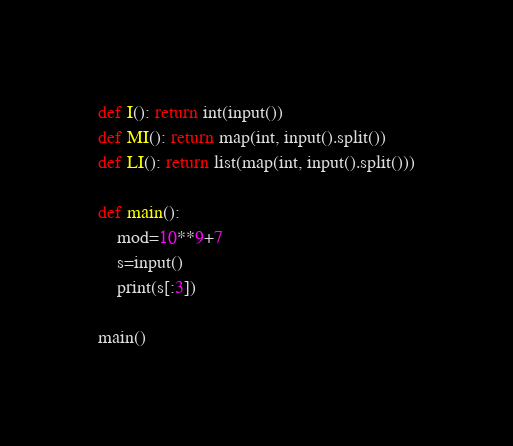Convert code to text. <code><loc_0><loc_0><loc_500><loc_500><_Python_>

def I(): return int(input())
def MI(): return map(int, input().split())
def LI(): return list(map(int, input().split()))

def main():
    mod=10**9+7
    s=input()
    print(s[:3])

main()
</code> 